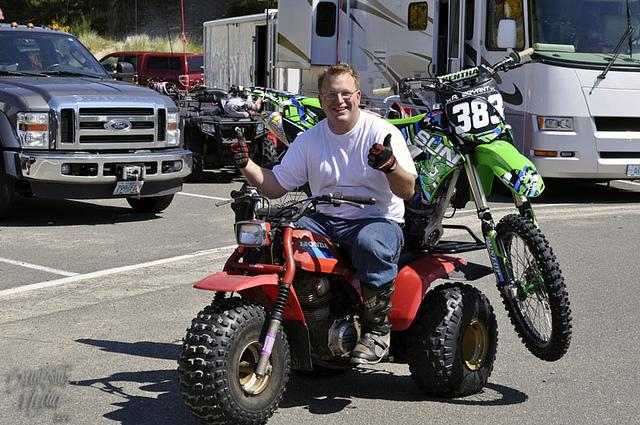Why does he have a bike on the back of his vehicle? Please explain your reasoning. transporting it. The bike looks like it is to be used in professional competition, and needs to be transported to the starting line, as he is not the one who is about to be using it. 